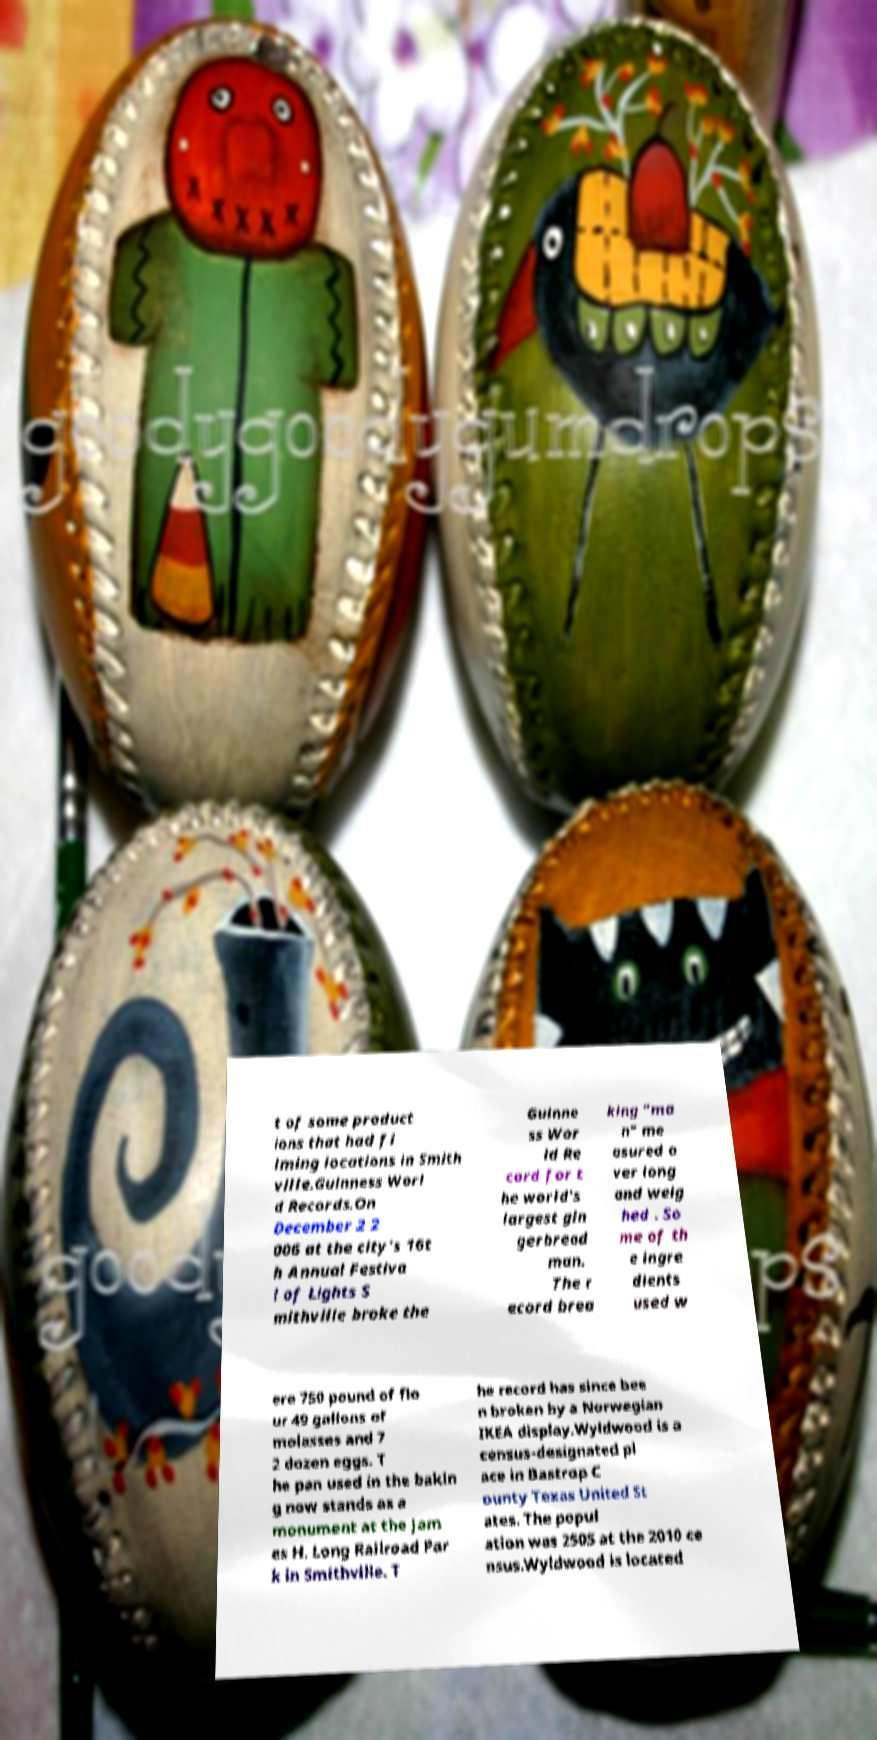Can you read and provide the text displayed in the image?This photo seems to have some interesting text. Can you extract and type it out for me? t of some product ions that had fi lming locations in Smith ville.Guinness Worl d Records.On December 2 2 006 at the city's 16t h Annual Festiva l of Lights S mithville broke the Guinne ss Wor ld Re cord for t he world's largest gin gerbread man. The r ecord brea king "ma n" me asured o ver long and weig hed . So me of th e ingre dients used w ere 750 pound of flo ur 49 gallons of molasses and 7 2 dozen eggs. T he pan used in the bakin g now stands as a monument at the Jam es H. Long Railroad Par k in Smithville. T he record has since bee n broken by a Norwegian IKEA display.Wyldwood is a census-designated pl ace in Bastrop C ounty Texas United St ates. The popul ation was 2505 at the 2010 ce nsus.Wyldwood is located 